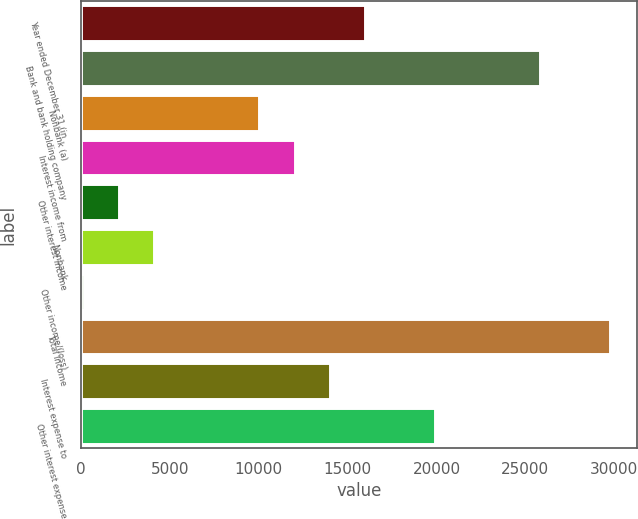Convert chart to OTSL. <chart><loc_0><loc_0><loc_500><loc_500><bar_chart><fcel>Year ended December 31 (in<fcel>Bank and bank holding company<fcel>Nonbank (a)<fcel>Interest income from<fcel>Other interest income<fcel>Nonbank<fcel>Other income/(loss)<fcel>Total income<fcel>Interest expense to<fcel>Other interest expense<nl><fcel>15962.6<fcel>25841.1<fcel>10035.5<fcel>12011.2<fcel>2132.7<fcel>4108.4<fcel>157<fcel>29792.5<fcel>13986.9<fcel>19914<nl></chart> 